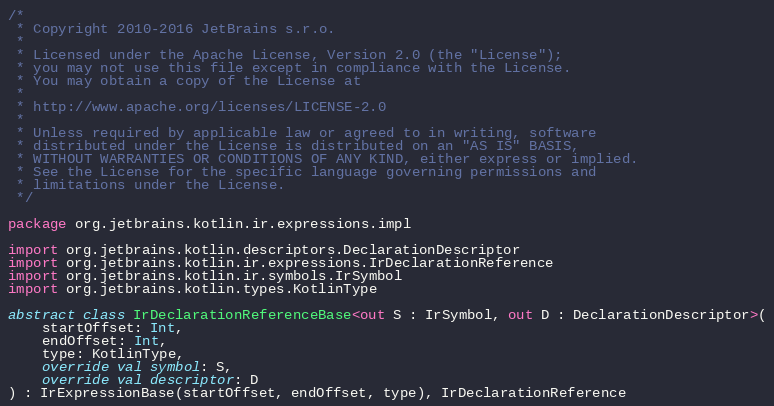Convert code to text. <code><loc_0><loc_0><loc_500><loc_500><_Kotlin_>/*
 * Copyright 2010-2016 JetBrains s.r.o.
 *
 * Licensed under the Apache License, Version 2.0 (the "License");
 * you may not use this file except in compliance with the License.
 * You may obtain a copy of the License at
 *
 * http://www.apache.org/licenses/LICENSE-2.0
 *
 * Unless required by applicable law or agreed to in writing, software
 * distributed under the License is distributed on an "AS IS" BASIS,
 * WITHOUT WARRANTIES OR CONDITIONS OF ANY KIND, either express or implied.
 * See the License for the specific language governing permissions and
 * limitations under the License.
 */

package org.jetbrains.kotlin.ir.expressions.impl

import org.jetbrains.kotlin.descriptors.DeclarationDescriptor
import org.jetbrains.kotlin.ir.expressions.IrDeclarationReference
import org.jetbrains.kotlin.ir.symbols.IrSymbol
import org.jetbrains.kotlin.types.KotlinType

abstract class IrDeclarationReferenceBase<out S : IrSymbol, out D : DeclarationDescriptor>(
    startOffset: Int,
    endOffset: Int,
    type: KotlinType,
    override val symbol: S,
    override val descriptor: D
) : IrExpressionBase(startOffset, endOffset, type), IrDeclarationReference</code> 